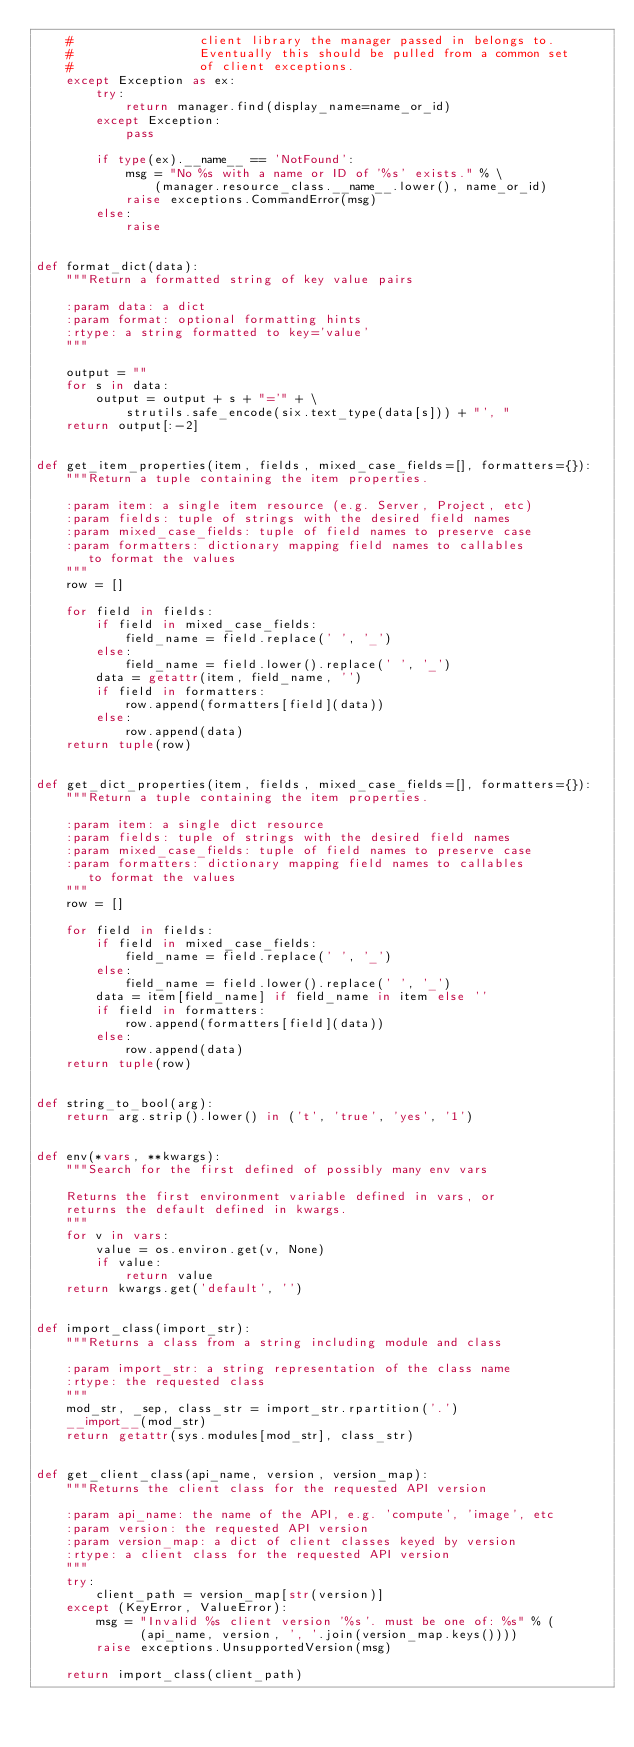<code> <loc_0><loc_0><loc_500><loc_500><_Python_>    #                 client library the manager passed in belongs to.
    #                 Eventually this should be pulled from a common set
    #                 of client exceptions.
    except Exception as ex:
        try:
            return manager.find(display_name=name_or_id)
        except Exception:
            pass

        if type(ex).__name__ == 'NotFound':
            msg = "No %s with a name or ID of '%s' exists." % \
                (manager.resource_class.__name__.lower(), name_or_id)
            raise exceptions.CommandError(msg)
        else:
            raise


def format_dict(data):
    """Return a formatted string of key value pairs

    :param data: a dict
    :param format: optional formatting hints
    :rtype: a string formatted to key='value'
    """

    output = ""
    for s in data:
        output = output + s + "='" + \
            strutils.safe_encode(six.text_type(data[s])) + "', "
    return output[:-2]


def get_item_properties(item, fields, mixed_case_fields=[], formatters={}):
    """Return a tuple containing the item properties.

    :param item: a single item resource (e.g. Server, Project, etc)
    :param fields: tuple of strings with the desired field names
    :param mixed_case_fields: tuple of field names to preserve case
    :param formatters: dictionary mapping field names to callables
       to format the values
    """
    row = []

    for field in fields:
        if field in mixed_case_fields:
            field_name = field.replace(' ', '_')
        else:
            field_name = field.lower().replace(' ', '_')
        data = getattr(item, field_name, '')
        if field in formatters:
            row.append(formatters[field](data))
        else:
            row.append(data)
    return tuple(row)


def get_dict_properties(item, fields, mixed_case_fields=[], formatters={}):
    """Return a tuple containing the item properties.

    :param item: a single dict resource
    :param fields: tuple of strings with the desired field names
    :param mixed_case_fields: tuple of field names to preserve case
    :param formatters: dictionary mapping field names to callables
       to format the values
    """
    row = []

    for field in fields:
        if field in mixed_case_fields:
            field_name = field.replace(' ', '_')
        else:
            field_name = field.lower().replace(' ', '_')
        data = item[field_name] if field_name in item else ''
        if field in formatters:
            row.append(formatters[field](data))
        else:
            row.append(data)
    return tuple(row)


def string_to_bool(arg):
    return arg.strip().lower() in ('t', 'true', 'yes', '1')


def env(*vars, **kwargs):
    """Search for the first defined of possibly many env vars

    Returns the first environment variable defined in vars, or
    returns the default defined in kwargs.
    """
    for v in vars:
        value = os.environ.get(v, None)
        if value:
            return value
    return kwargs.get('default', '')


def import_class(import_str):
    """Returns a class from a string including module and class

    :param import_str: a string representation of the class name
    :rtype: the requested class
    """
    mod_str, _sep, class_str = import_str.rpartition('.')
    __import__(mod_str)
    return getattr(sys.modules[mod_str], class_str)


def get_client_class(api_name, version, version_map):
    """Returns the client class for the requested API version

    :param api_name: the name of the API, e.g. 'compute', 'image', etc
    :param version: the requested API version
    :param version_map: a dict of client classes keyed by version
    :rtype: a client class for the requested API version
    """
    try:
        client_path = version_map[str(version)]
    except (KeyError, ValueError):
        msg = "Invalid %s client version '%s'. must be one of: %s" % (
              (api_name, version, ', '.join(version_map.keys())))
        raise exceptions.UnsupportedVersion(msg)

    return import_class(client_path)

</code> 